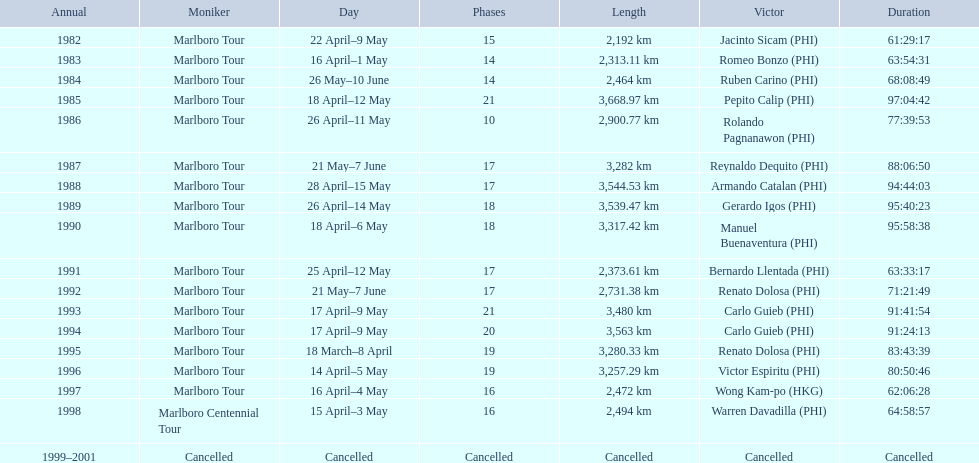What was the maximum distance journeyed for the marlboro tour? 3,668.97 km. 